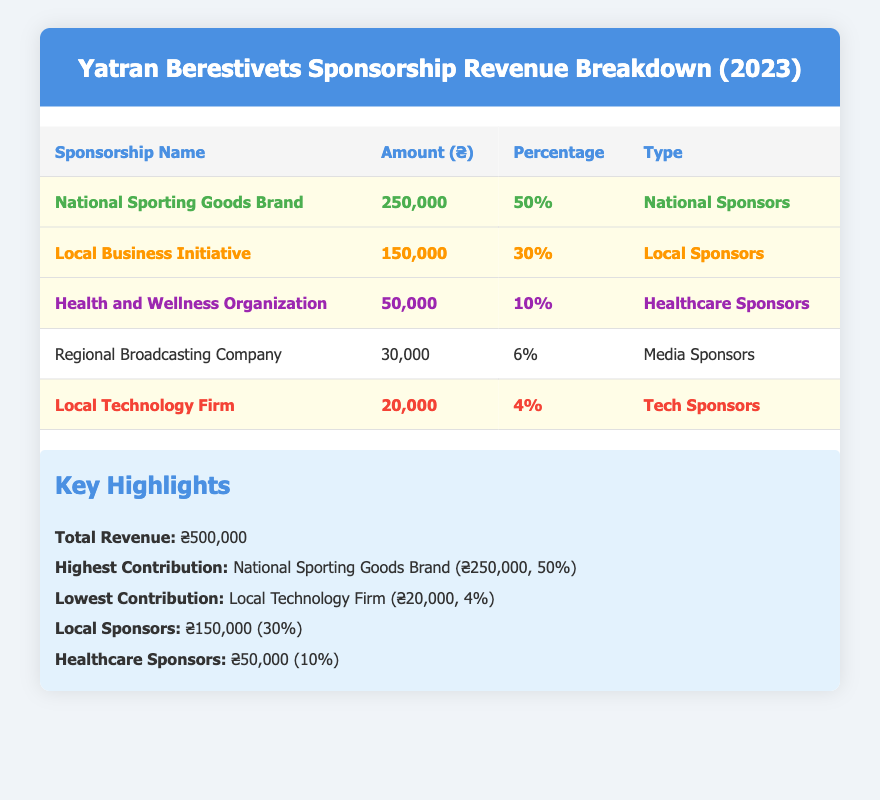What is the total revenue from sponsorships for Yatran Berestivets in 2023? The total revenue is clearly stated in the summary section of the table as ₴500,000.
Answer: ₴500,000 Which sponsorship provides the highest revenue? The 'National Sporting Goods Brand' row in the table indicates that it contributes the highest amount of ₴250,000, which is highlighted as the highest contribution.
Answer: National Sporting Goods Brand What percentage of the total sponsorship revenue comes from local sponsors? The 'Local Business Initiative' row indicates that local sponsors contribute ₴150,000, which is 30% of the total revenue of ₴500,000. This percentage is also highlighted in the summary.
Answer: 30% Is the 'Local Technology Firm' the lowest contributor among sponsors? The table highlights 'Local Technology Firm' as having the lowest amount of ₴20,000 and 4%, confirming it is indeed the lowest contributor.
Answer: Yes What is the total revenue from healthcare sponsors? The table shows that the 'Health and Wellness Organization' contributes ₴50,000, which means the total healthcare sponsorship is ₴50,000 as there is only one healthcare sponsor listed.
Answer: ₴50,000 How much revenue do regional broadcasting companies contribute compared to national sporting goods brands? The table states that 'Regional Broadcasting Company' contributes ₴30,000 while 'National Sporting Goods Brand' contributes ₴250,000. The difference is ₴250,000 - ₴30,000 = ₴220,000.
Answer: ₴220,000 If you combine the amounts from local sponsors together, what will be the total? The local sponsors are 'Local Business Initiative' (₴150,000) and 'Local Technology Firm' (₴20,000). Summing these amounts gives ₴150,000 + ₴20,000 = ₴170,000.
Answer: ₴170,000 Does the table indicate that more than half of the total revenue comes from healthcare sponsors? The total revenue from healthcare sponsors is ₴50,000, which is 10% of the total revenue of ₴500,000. Since 10% is not more than 50%, the statement is false.
Answer: No What is the combined percentage contribution of media and tech sponsors? The 'Regional Broadcasting Company' (media) contributes 6% and 'Local Technology Firm' (tech) contributes 4%. Combined, they contribute 6% + 4% = 10%.
Answer: 10% Which type of sponsor contributes the least amount, and how much is that? The data shows that the 'Local Technology Firm' contributes ₴20,000, making it the least contributor and highlighted in the table.
Answer: Local Technology Firm, ₴20,000 